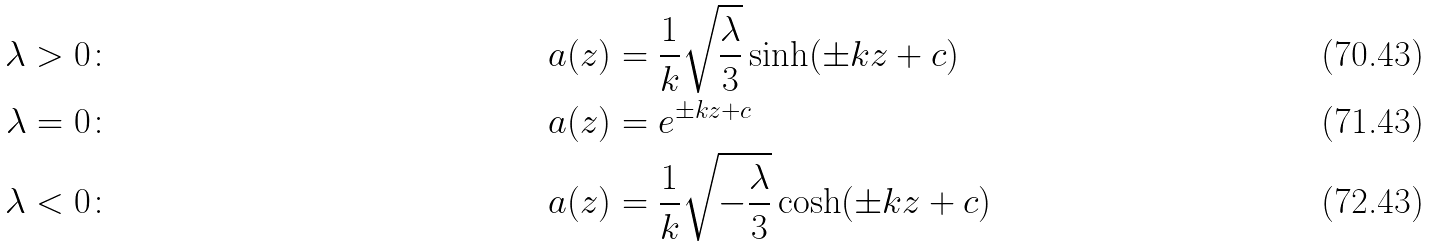Convert formula to latex. <formula><loc_0><loc_0><loc_500><loc_500>\lambda > 0 & \colon & a ( z ) & = \frac { 1 } { k } \sqrt { \frac { \lambda } { 3 } } \sinh ( \pm k z + c ) \\ \lambda = 0 & \colon & a ( z ) & = e ^ { \pm k z + c } \\ \lambda < 0 & \colon & a ( z ) & = \frac { 1 } { k } \sqrt { - \frac { \lambda } { 3 } } \cosh ( \pm k z + c )</formula> 